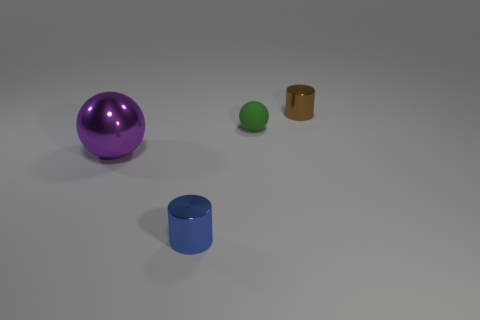Add 4 tiny brown metal objects. How many objects exist? 8 Subtract all rubber objects. Subtract all small green spheres. How many objects are left? 2 Add 2 metallic spheres. How many metallic spheres are left? 3 Add 1 tiny red spheres. How many tiny red spheres exist? 1 Subtract 0 cyan blocks. How many objects are left? 4 